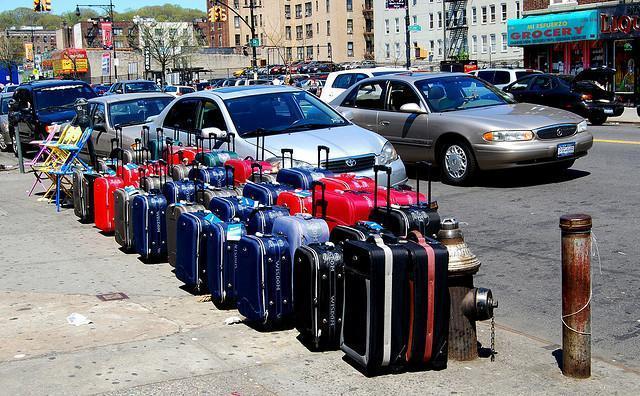How many cars are visible?
Give a very brief answer. 5. How many suitcases are there?
Give a very brief answer. 7. How many red umbrellas do you see?
Give a very brief answer. 0. 